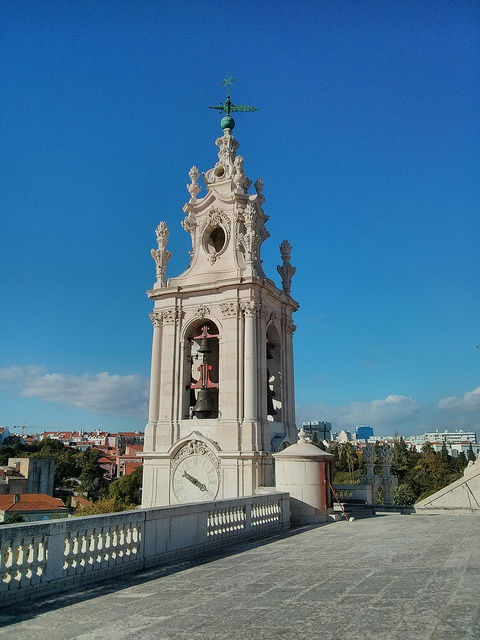Describe the objects in this image and their specific colors. I can see a clock in blue, lightgray, darkgray, and gray tones in this image. 